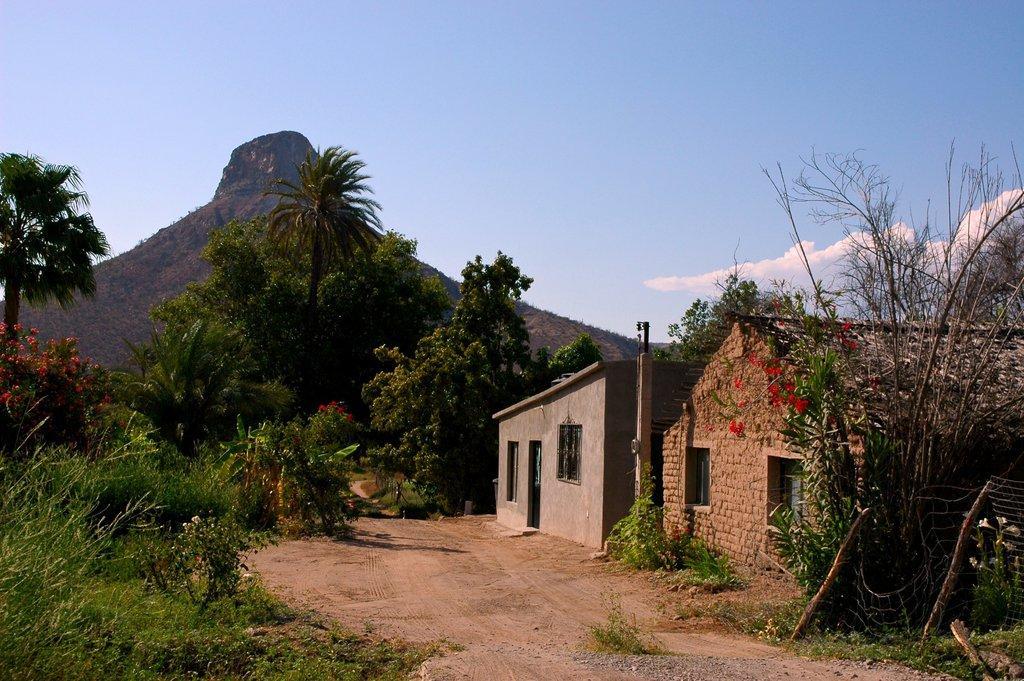How would you summarize this image in a sentence or two? On the right side of the picture, we see buildings in grey and brown color. Beside that, we see an electric pole and trees. On the left side of the picture, we see trees and plants. There are trees and hills in the background. At the top of the picture, we see the sky and the clouds. 